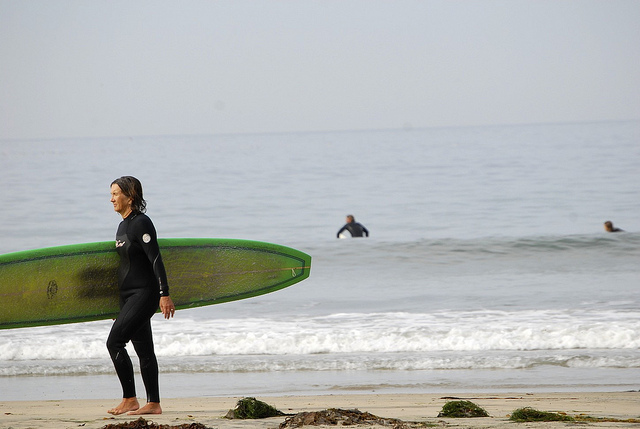Can you describe the positioning of the surfers relative to each other? Yes, one individual is prominently in the foreground, walking along the shore with a surfboard. Behind this person, there are two more individuals in the water. One appears to be sitting or floating on a surfboard, while the other, slightly further out in the water, seems to be waiting for a wave to surf. The positioning suggests a typical surfing setup with surfers at varying stages of preparing, waiting, or resting. 